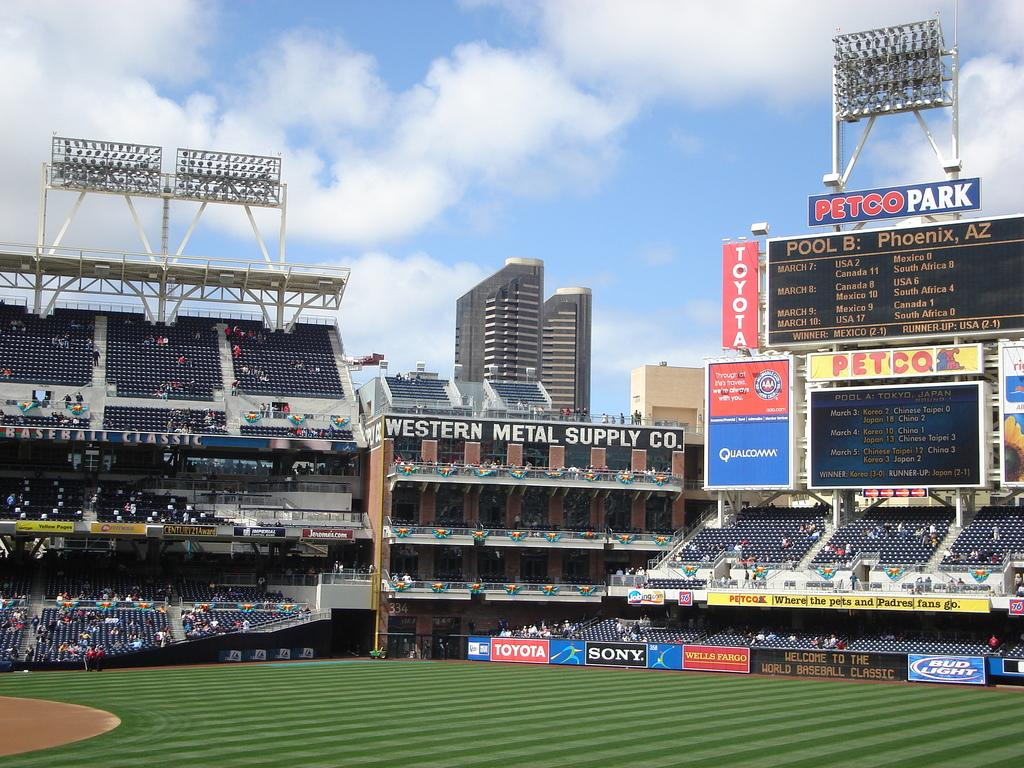<image>
Render a clear and concise summary of the photo. Petco park baseball field with several ads for petco and toyota. 